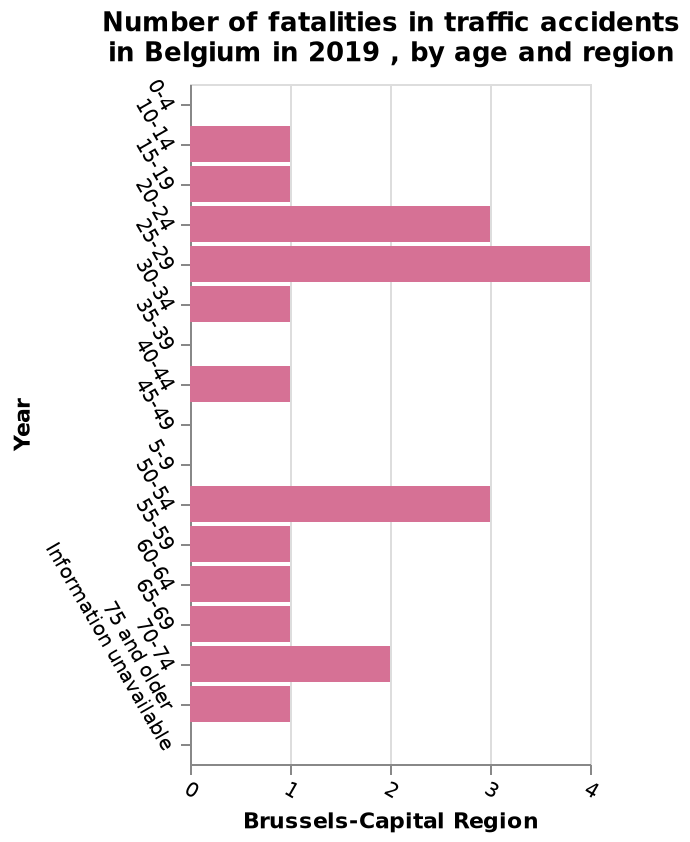<image>
What does the y-axis represent in the bar diagram? The y-axis represents the age categories, ranging from 0-4 to "Information unavailable". please enumerates aspects of the construction of the chart Here a bar diagram is titled Number of fatalities in traffic accidents in Belgium in 2019 , by age and region. The x-axis plots Brussels-Capital Region. A categorical scale starting with 0-4 and ending with Information unavailable can be found along the y-axis, marked Year. Which region is plotted on the x-axis? The Brussels-Capital Region is plotted on the x-axis. Offer a thorough analysis of the image. People aged between 20 - 29 were most likely to be killed in traffic accidents. A total of 7 were in these age groups. Three people died in traffic accidents between age group 50  - 54. 2 people died in the age group 70 - 74. No one below 9 died. No one died between 35- 39 or between 45 - 49. In other age groups, one person died. Which age group had the highest number of car accident fatalities in 2019?  The age group between 25 to 29 had the highest number of car accident fatalities in 2019. 